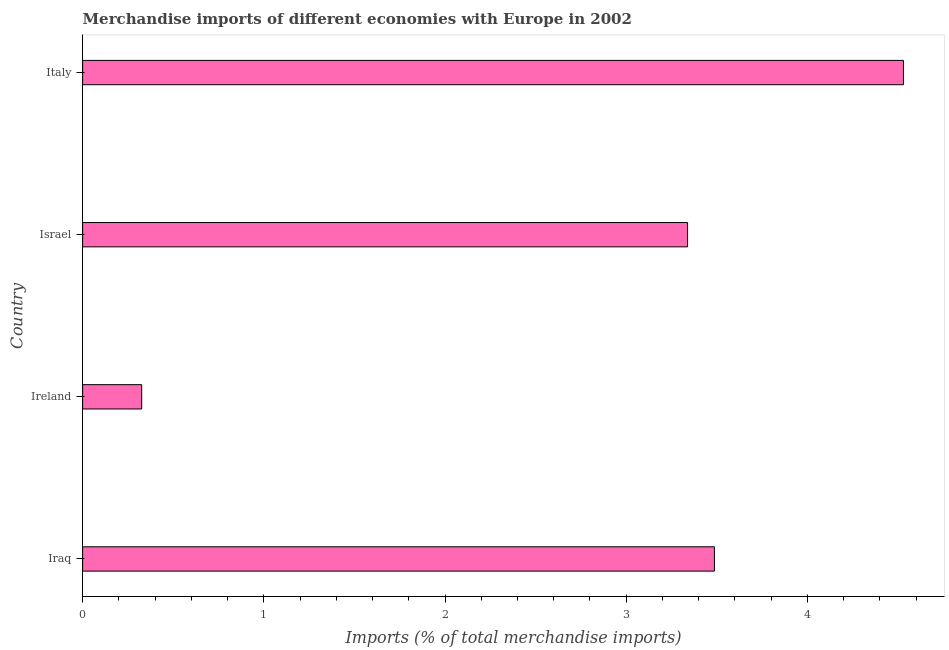What is the title of the graph?
Offer a very short reply. Merchandise imports of different economies with Europe in 2002. What is the label or title of the X-axis?
Ensure brevity in your answer.  Imports (% of total merchandise imports). What is the merchandise imports in Italy?
Your answer should be compact. 4.53. Across all countries, what is the maximum merchandise imports?
Provide a short and direct response. 4.53. Across all countries, what is the minimum merchandise imports?
Provide a succinct answer. 0.33. In which country was the merchandise imports minimum?
Provide a succinct answer. Ireland. What is the sum of the merchandise imports?
Keep it short and to the point. 11.68. What is the difference between the merchandise imports in Ireland and Italy?
Keep it short and to the point. -4.2. What is the average merchandise imports per country?
Your answer should be compact. 2.92. What is the median merchandise imports?
Your answer should be very brief. 3.41. In how many countries, is the merchandise imports greater than 1.4 %?
Offer a very short reply. 3. What is the ratio of the merchandise imports in Iraq to that in Israel?
Provide a succinct answer. 1.04. Is the merchandise imports in Iraq less than that in Ireland?
Provide a succinct answer. No. What is the difference between the highest and the second highest merchandise imports?
Give a very brief answer. 1.04. What is the difference between two consecutive major ticks on the X-axis?
Make the answer very short. 1. Are the values on the major ticks of X-axis written in scientific E-notation?
Provide a succinct answer. No. What is the Imports (% of total merchandise imports) of Iraq?
Keep it short and to the point. 3.49. What is the Imports (% of total merchandise imports) in Ireland?
Offer a terse response. 0.33. What is the Imports (% of total merchandise imports) in Israel?
Provide a short and direct response. 3.34. What is the Imports (% of total merchandise imports) in Italy?
Make the answer very short. 4.53. What is the difference between the Imports (% of total merchandise imports) in Iraq and Ireland?
Your answer should be compact. 3.16. What is the difference between the Imports (% of total merchandise imports) in Iraq and Israel?
Make the answer very short. 0.15. What is the difference between the Imports (% of total merchandise imports) in Iraq and Italy?
Give a very brief answer. -1.04. What is the difference between the Imports (% of total merchandise imports) in Ireland and Israel?
Ensure brevity in your answer.  -3.01. What is the difference between the Imports (% of total merchandise imports) in Ireland and Italy?
Give a very brief answer. -4.2. What is the difference between the Imports (% of total merchandise imports) in Israel and Italy?
Offer a very short reply. -1.19. What is the ratio of the Imports (% of total merchandise imports) in Iraq to that in Ireland?
Your answer should be very brief. 10.7. What is the ratio of the Imports (% of total merchandise imports) in Iraq to that in Israel?
Keep it short and to the point. 1.04. What is the ratio of the Imports (% of total merchandise imports) in Iraq to that in Italy?
Ensure brevity in your answer.  0.77. What is the ratio of the Imports (% of total merchandise imports) in Ireland to that in Israel?
Your response must be concise. 0.1. What is the ratio of the Imports (% of total merchandise imports) in Ireland to that in Italy?
Your answer should be very brief. 0.07. What is the ratio of the Imports (% of total merchandise imports) in Israel to that in Italy?
Your answer should be very brief. 0.74. 